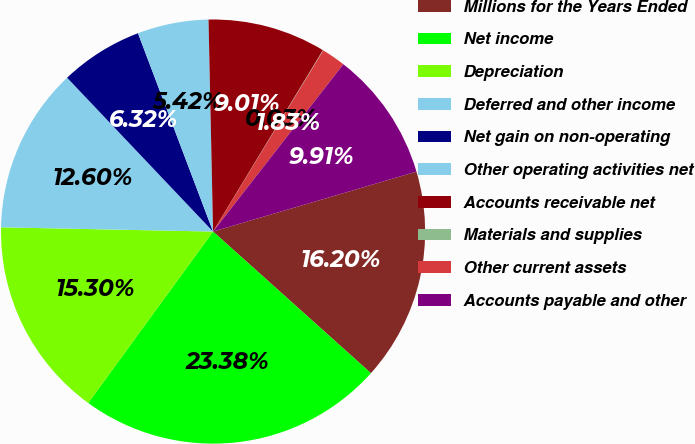Convert chart. <chart><loc_0><loc_0><loc_500><loc_500><pie_chart><fcel>Millions for the Years Ended<fcel>Net income<fcel>Depreciation<fcel>Deferred and other income<fcel>Net gain on non-operating<fcel>Other operating activities net<fcel>Accounts receivable net<fcel>Materials and supplies<fcel>Other current assets<fcel>Accounts payable and other<nl><fcel>16.2%<fcel>23.38%<fcel>15.3%<fcel>12.6%<fcel>6.32%<fcel>5.42%<fcel>9.01%<fcel>0.03%<fcel>1.83%<fcel>9.91%<nl></chart> 